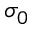<formula> <loc_0><loc_0><loc_500><loc_500>\sigma _ { 0 }</formula> 